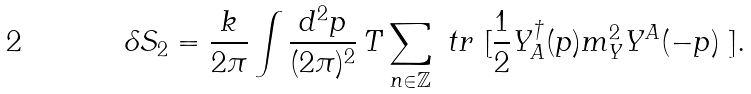<formula> <loc_0><loc_0><loc_500><loc_500>\delta S _ { \text {2} } = \frac { k } { 2 \pi } \int \frac { d ^ { 2 } p } { ( 2 \pi ) ^ { 2 } } \, T \sum _ { n \in \mathbb { Z } } \ t r \text { [} & \frac { 1 } { 2 } Y ^ { \dagger } _ { A } ( p ) m ^ { 2 } _ { Y } Y ^ { A } ( - p ) \text { ]} .</formula> 